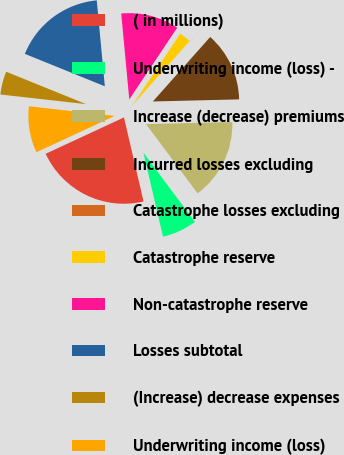Convert chart to OTSL. <chart><loc_0><loc_0><loc_500><loc_500><pie_chart><fcel>( in millions)<fcel>Underwriting income (loss) -<fcel>Increase (decrease) premiums<fcel>Incurred losses excluding<fcel>Catastrophe losses excluding<fcel>Catastrophe reserve<fcel>Non-catastrophe reserve<fcel>Losses subtotal<fcel>(Increase) decrease expenses<fcel>Underwriting income (loss)<nl><fcel>21.73%<fcel>6.53%<fcel>15.21%<fcel>13.04%<fcel>0.01%<fcel>2.18%<fcel>10.87%<fcel>17.38%<fcel>4.35%<fcel>8.7%<nl></chart> 